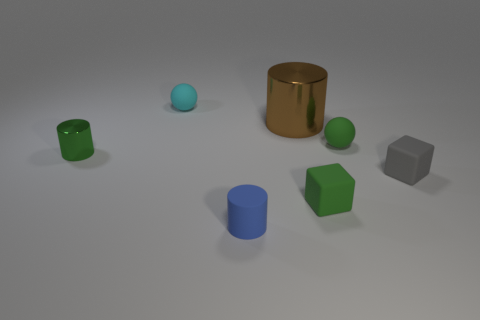Subtract all shiny cylinders. How many cylinders are left? 1 Add 1 rubber blocks. How many objects exist? 8 Subtract all spheres. How many objects are left? 5 Subtract 1 green balls. How many objects are left? 6 Subtract all purple cylinders. Subtract all blue balls. How many cylinders are left? 3 Subtract all tiny yellow matte blocks. Subtract all rubber cylinders. How many objects are left? 6 Add 1 tiny cyan balls. How many tiny cyan balls are left? 2 Add 2 large green matte cubes. How many large green matte cubes exist? 2 